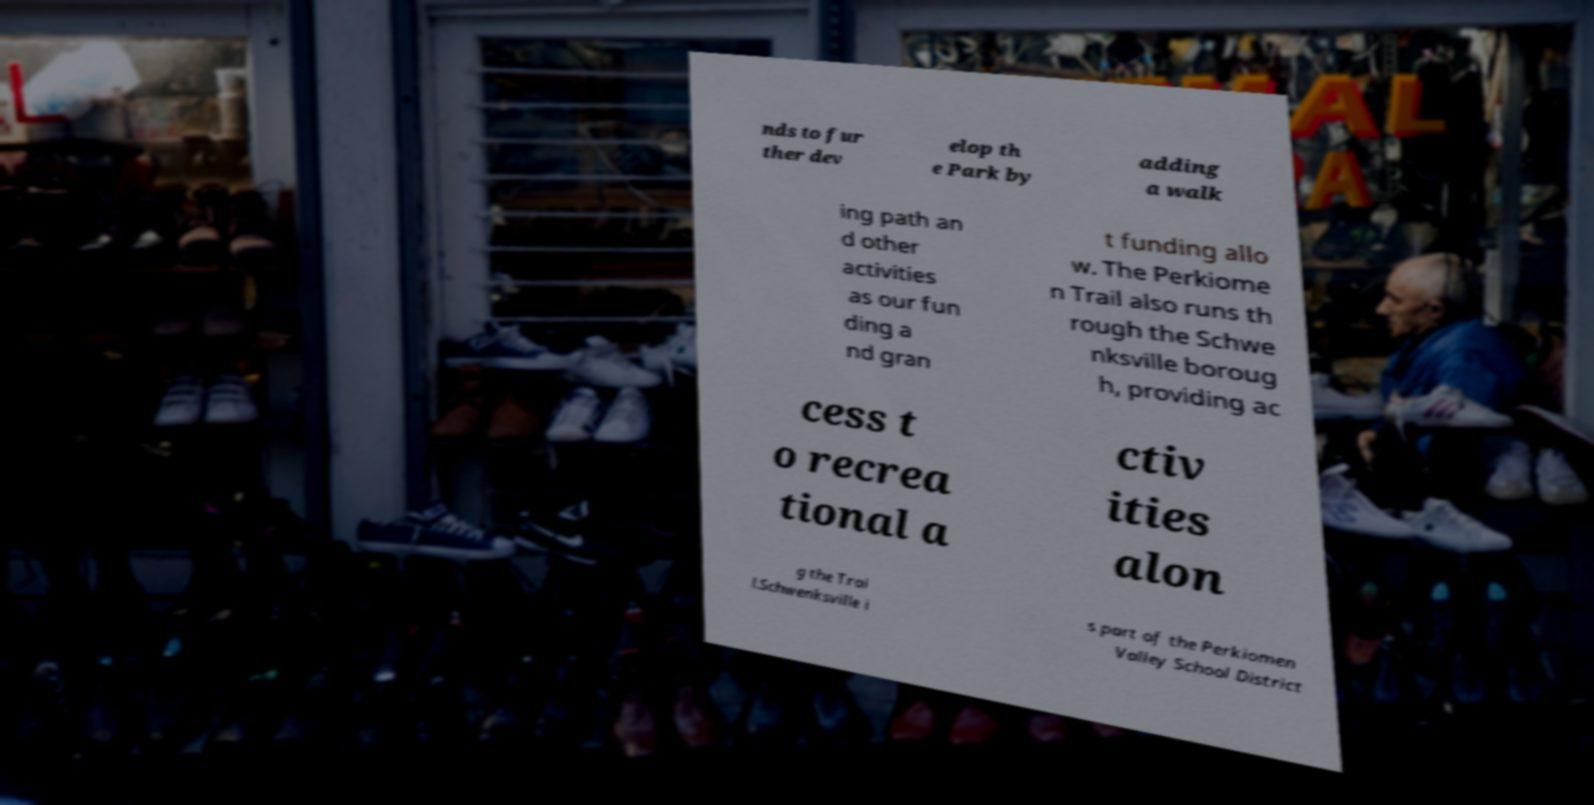There's text embedded in this image that I need extracted. Can you transcribe it verbatim? nds to fur ther dev elop th e Park by adding a walk ing path an d other activities as our fun ding a nd gran t funding allo w. The Perkiome n Trail also runs th rough the Schwe nksville boroug h, providing ac cess t o recrea tional a ctiv ities alon g the Trai l.Schwenksville i s part of the Perkiomen Valley School District 